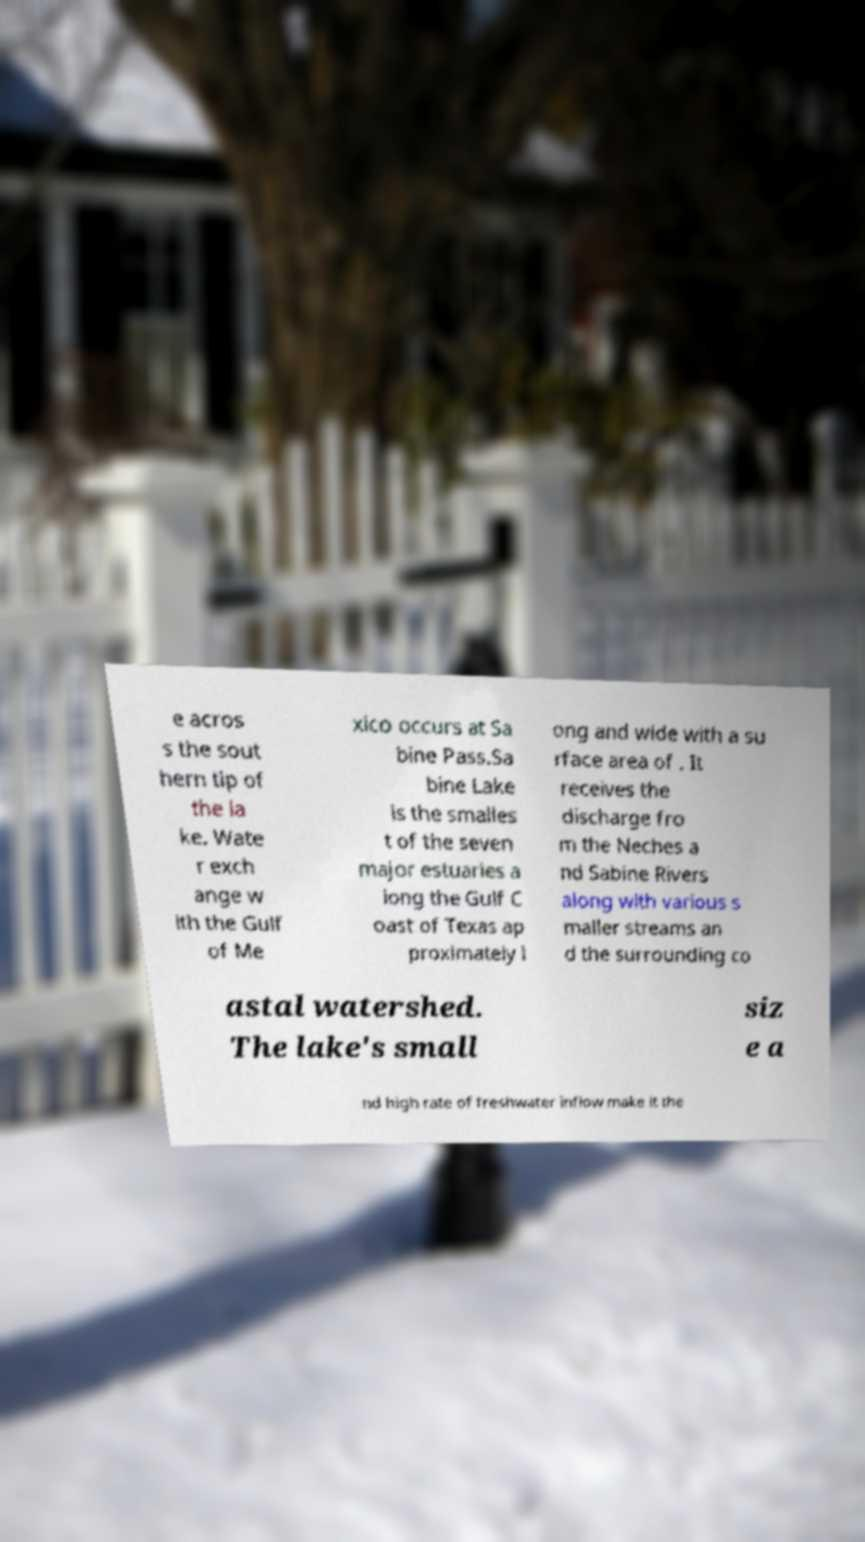There's text embedded in this image that I need extracted. Can you transcribe it verbatim? e acros s the sout hern tip of the la ke. Wate r exch ange w ith the Gulf of Me xico occurs at Sa bine Pass.Sa bine Lake is the smalles t of the seven major estuaries a long the Gulf C oast of Texas ap proximately l ong and wide with a su rface area of . It receives the discharge fro m the Neches a nd Sabine Rivers along with various s maller streams an d the surrounding co astal watershed. The lake's small siz e a nd high rate of freshwater inflow make it the 